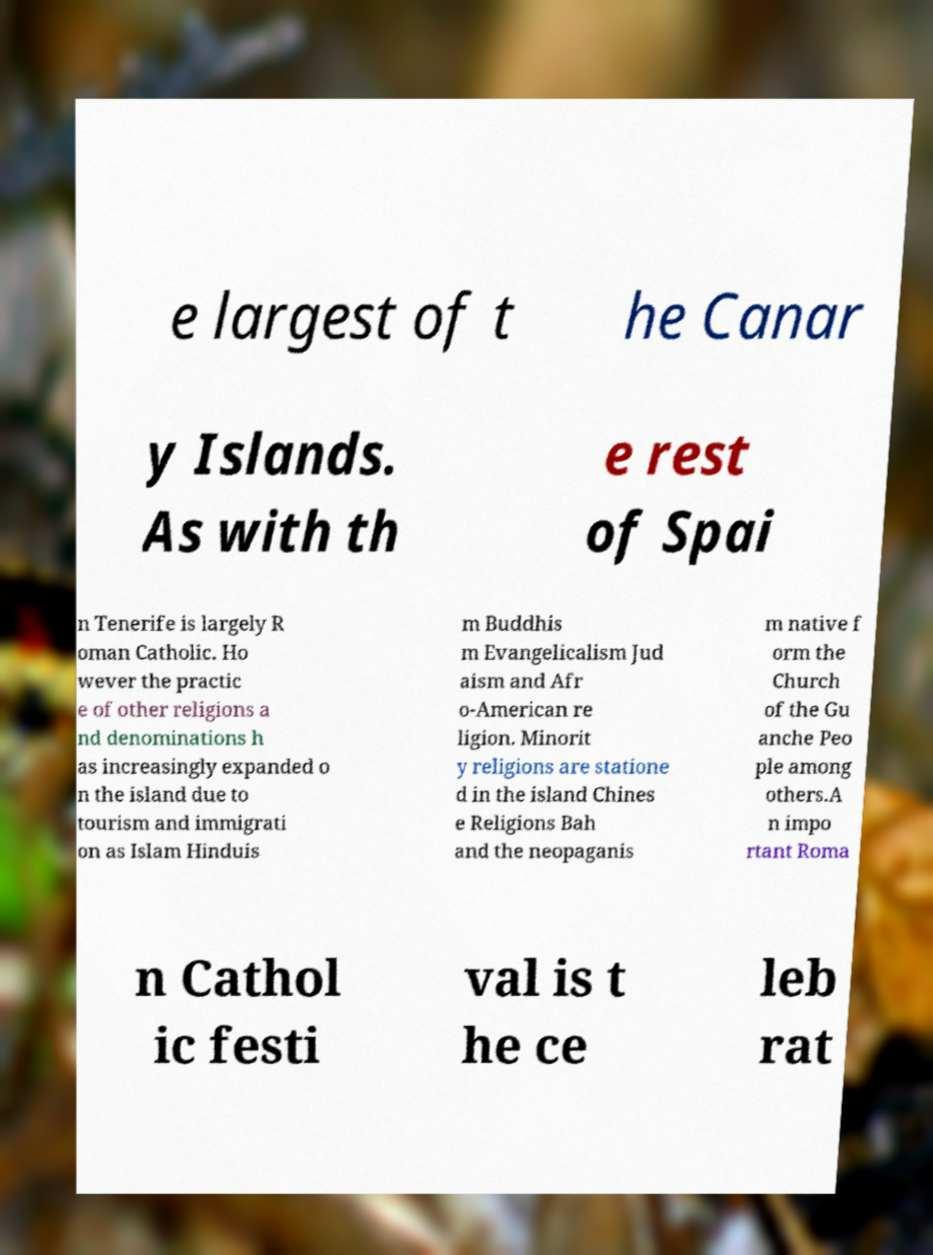For documentation purposes, I need the text within this image transcribed. Could you provide that? e largest of t he Canar y Islands. As with th e rest of Spai n Tenerife is largely R oman Catholic. Ho wever the practic e of other religions a nd denominations h as increasingly expanded o n the island due to tourism and immigrati on as Islam Hinduis m Buddhis m Evangelicalism Jud aism and Afr o-American re ligion. Minorit y religions are statione d in the island Chines e Religions Bah and the neopaganis m native f orm the Church of the Gu anche Peo ple among others.A n impo rtant Roma n Cathol ic festi val is t he ce leb rat 